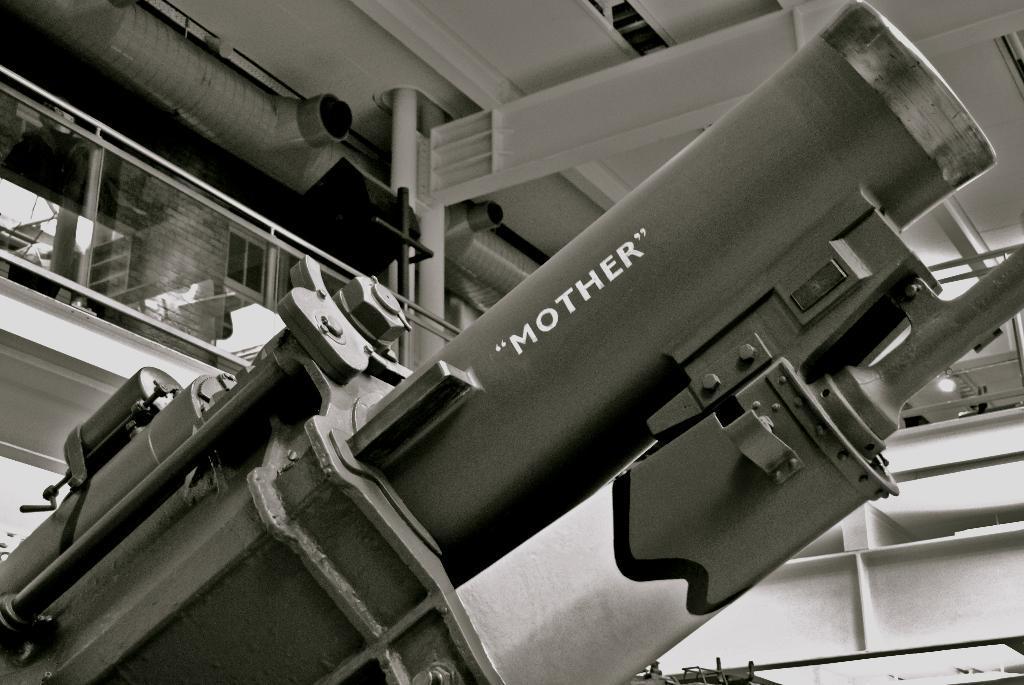In one or two sentences, can you explain what this image depicts? In this picture I can see a machine in the building and I can see text on it. 